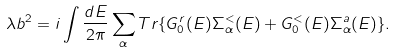<formula> <loc_0><loc_0><loc_500><loc_500>\lambda b ^ { 2 } = i \int \frac { d E } { 2 \pi } \sum _ { \alpha } T r \{ G _ { 0 } ^ { r } ( E ) \Sigma _ { \alpha } ^ { < } ( E ) + G _ { 0 } ^ { < } ( E ) \Sigma _ { \alpha } ^ { a } ( E ) \} .</formula> 